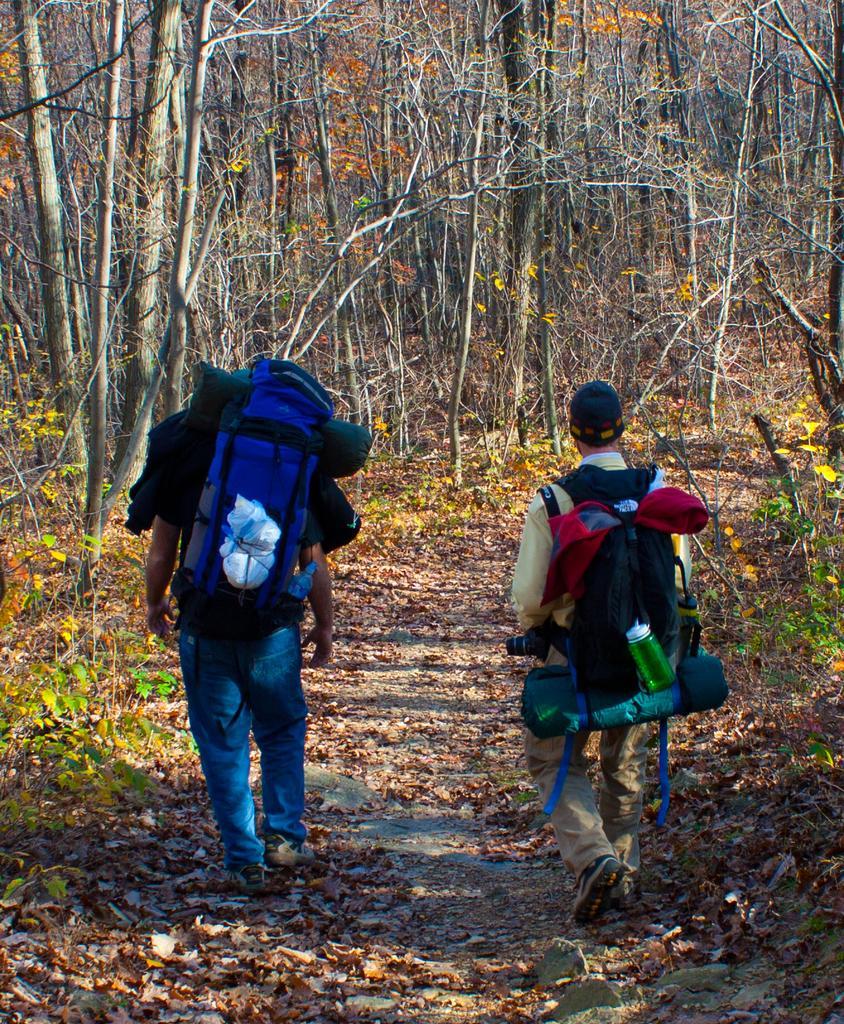Can you describe this image briefly? In this picture we can see two persons carrying bags and walking on the ground, dried leaves, bottles and in the background we can see trees. 